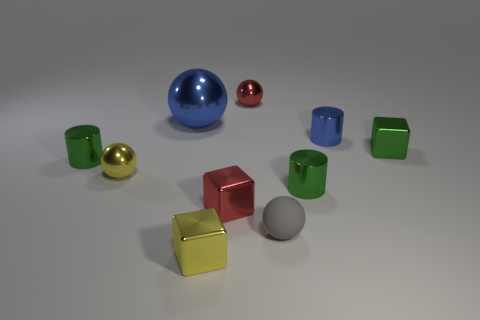Are there any tiny gray things behind the green cylinder that is to the left of the tiny red block?
Give a very brief answer. No. What is the material of the red thing behind the small blue metal thing?
Keep it short and to the point. Metal. Is the shape of the big metallic thing the same as the small gray object?
Offer a very short reply. Yes. There is a tiny metallic ball that is on the left side of the small red thing in front of the small green cylinder on the left side of the small gray matte sphere; what is its color?
Give a very brief answer. Yellow. How many tiny green shiny things are the same shape as the tiny blue metal object?
Your answer should be compact. 2. How big is the sphere that is to the right of the small metal sphere that is behind the small blue cylinder?
Offer a terse response. Small. Does the yellow metallic cube have the same size as the blue metal cylinder?
Provide a succinct answer. Yes. Is there a small metal thing on the left side of the yellow object that is on the right side of the shiny sphere that is in front of the small blue metallic cylinder?
Your response must be concise. Yes. The red block has what size?
Provide a succinct answer. Small. What number of other matte objects are the same size as the gray thing?
Offer a terse response. 0. 